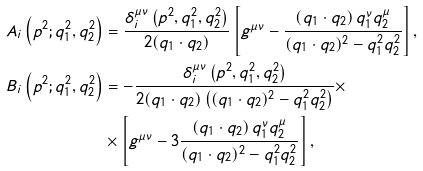Convert formula to latex. <formula><loc_0><loc_0><loc_500><loc_500>A _ { i } \left ( p ^ { 2 } ; q _ { 1 } ^ { 2 } , q _ { 2 } ^ { 2 } \right ) & = \frac { \delta _ { i } ^ { \mu \nu } \left ( p ^ { 2 } , q _ { 1 } ^ { 2 } , q _ { 2 } ^ { 2 } \right ) } { 2 ( q _ { 1 } \cdot q _ { 2 } ) } \left [ g ^ { \mu \nu } - \frac { ( q _ { 1 } \cdot q _ { 2 } ) \, q _ { 1 } ^ { \nu } q _ { 2 } ^ { \mu } } { ( q _ { 1 } \cdot q _ { 2 } ) ^ { 2 } - q _ { 1 } ^ { 2 } q _ { 2 } ^ { 2 } } \right ] , \\ B _ { i } \left ( p ^ { 2 } ; q _ { 1 } ^ { 2 } , q _ { 2 } ^ { 2 } \right ) & = - \frac { \delta _ { i } ^ { \mu \nu } \left ( p ^ { 2 } , q _ { 1 } ^ { 2 } , q _ { 2 } ^ { 2 } \right ) } { 2 ( q _ { 1 } \cdot q _ { 2 } ) \left ( ( q _ { 1 } \cdot q _ { 2 } ) ^ { 2 } - q _ { 1 } ^ { 2 } q _ { 2 } ^ { 2 } \right ) } \times \\ & \times \left [ g ^ { \mu \nu } - 3 \frac { ( q _ { 1 } \cdot q _ { 2 } ) \, q _ { 1 } ^ { \nu } q _ { 2 } ^ { \mu } } { ( q _ { 1 } \cdot q _ { 2 } ) ^ { 2 } - q _ { 1 } ^ { 2 } q _ { 2 } ^ { 2 } } \right ] ,</formula> 